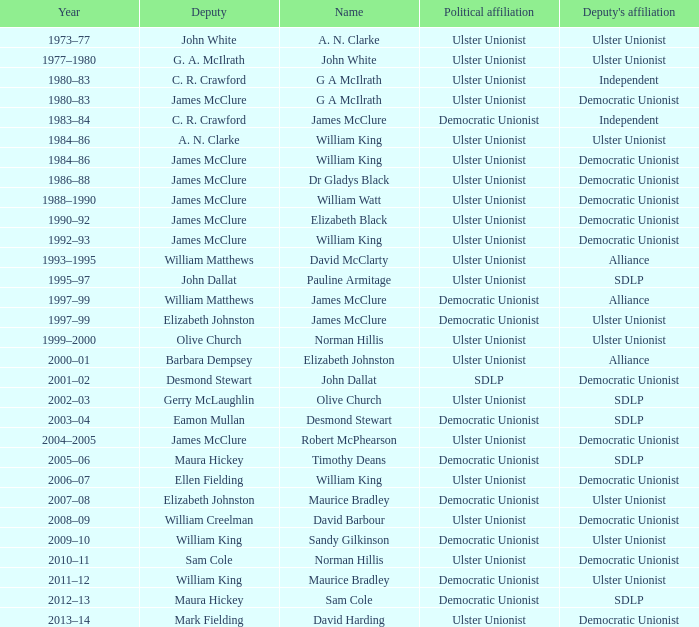What Year was james mcclure Deputy, and the Name is robert mcphearson? 2004–2005. 